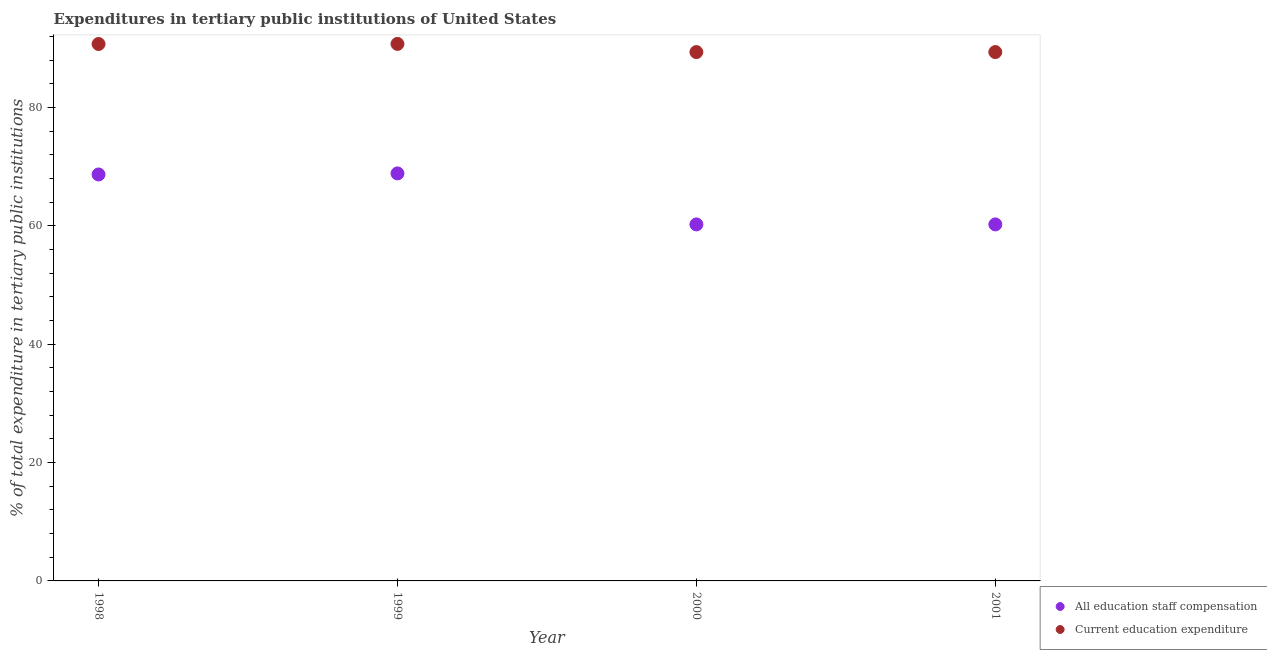How many different coloured dotlines are there?
Provide a short and direct response. 2. What is the expenditure in education in 1999?
Your response must be concise. 90.74. Across all years, what is the maximum expenditure in staff compensation?
Ensure brevity in your answer.  68.86. Across all years, what is the minimum expenditure in staff compensation?
Your answer should be compact. 60.24. In which year was the expenditure in staff compensation maximum?
Offer a very short reply. 1999. What is the total expenditure in education in the graph?
Keep it short and to the point. 360.19. What is the difference between the expenditure in staff compensation in 1998 and that in 2000?
Your response must be concise. 8.44. What is the difference between the expenditure in staff compensation in 2001 and the expenditure in education in 2000?
Your answer should be compact. -29.12. What is the average expenditure in staff compensation per year?
Provide a succinct answer. 64.51. In the year 1998, what is the difference between the expenditure in staff compensation and expenditure in education?
Your answer should be compact. -22.05. What is the ratio of the expenditure in staff compensation in 1999 to that in 2001?
Your answer should be compact. 1.14. What is the difference between the highest and the second highest expenditure in staff compensation?
Give a very brief answer. 0.18. What is the difference between the highest and the lowest expenditure in staff compensation?
Keep it short and to the point. 8.62. Does the expenditure in education monotonically increase over the years?
Give a very brief answer. No. Is the expenditure in staff compensation strictly greater than the expenditure in education over the years?
Provide a succinct answer. No. Is the expenditure in education strictly less than the expenditure in staff compensation over the years?
Ensure brevity in your answer.  No. What is the difference between two consecutive major ticks on the Y-axis?
Offer a terse response. 20. Are the values on the major ticks of Y-axis written in scientific E-notation?
Provide a short and direct response. No. Does the graph contain any zero values?
Offer a very short reply. No. Does the graph contain grids?
Give a very brief answer. No. Where does the legend appear in the graph?
Your answer should be very brief. Bottom right. How are the legend labels stacked?
Make the answer very short. Vertical. What is the title of the graph?
Keep it short and to the point. Expenditures in tertiary public institutions of United States. What is the label or title of the Y-axis?
Your answer should be very brief. % of total expenditure in tertiary public institutions. What is the % of total expenditure in tertiary public institutions of All education staff compensation in 1998?
Make the answer very short. 68.68. What is the % of total expenditure in tertiary public institutions of Current education expenditure in 1998?
Make the answer very short. 90.73. What is the % of total expenditure in tertiary public institutions in All education staff compensation in 1999?
Your response must be concise. 68.86. What is the % of total expenditure in tertiary public institutions of Current education expenditure in 1999?
Give a very brief answer. 90.74. What is the % of total expenditure in tertiary public institutions in All education staff compensation in 2000?
Make the answer very short. 60.24. What is the % of total expenditure in tertiary public institutions of Current education expenditure in 2000?
Ensure brevity in your answer.  89.36. What is the % of total expenditure in tertiary public institutions of All education staff compensation in 2001?
Make the answer very short. 60.24. What is the % of total expenditure in tertiary public institutions in Current education expenditure in 2001?
Your response must be concise. 89.36. Across all years, what is the maximum % of total expenditure in tertiary public institutions of All education staff compensation?
Make the answer very short. 68.86. Across all years, what is the maximum % of total expenditure in tertiary public institutions in Current education expenditure?
Offer a terse response. 90.74. Across all years, what is the minimum % of total expenditure in tertiary public institutions of All education staff compensation?
Provide a short and direct response. 60.24. Across all years, what is the minimum % of total expenditure in tertiary public institutions of Current education expenditure?
Give a very brief answer. 89.36. What is the total % of total expenditure in tertiary public institutions of All education staff compensation in the graph?
Ensure brevity in your answer.  258.02. What is the total % of total expenditure in tertiary public institutions of Current education expenditure in the graph?
Your answer should be very brief. 360.19. What is the difference between the % of total expenditure in tertiary public institutions of All education staff compensation in 1998 and that in 1999?
Keep it short and to the point. -0.18. What is the difference between the % of total expenditure in tertiary public institutions of Current education expenditure in 1998 and that in 1999?
Ensure brevity in your answer.  -0.02. What is the difference between the % of total expenditure in tertiary public institutions in All education staff compensation in 1998 and that in 2000?
Give a very brief answer. 8.44. What is the difference between the % of total expenditure in tertiary public institutions in Current education expenditure in 1998 and that in 2000?
Make the answer very short. 1.36. What is the difference between the % of total expenditure in tertiary public institutions of All education staff compensation in 1998 and that in 2001?
Your answer should be very brief. 8.44. What is the difference between the % of total expenditure in tertiary public institutions in Current education expenditure in 1998 and that in 2001?
Make the answer very short. 1.36. What is the difference between the % of total expenditure in tertiary public institutions of All education staff compensation in 1999 and that in 2000?
Offer a terse response. 8.62. What is the difference between the % of total expenditure in tertiary public institutions of Current education expenditure in 1999 and that in 2000?
Provide a succinct answer. 1.38. What is the difference between the % of total expenditure in tertiary public institutions in All education staff compensation in 1999 and that in 2001?
Your answer should be compact. 8.62. What is the difference between the % of total expenditure in tertiary public institutions of Current education expenditure in 1999 and that in 2001?
Your response must be concise. 1.38. What is the difference between the % of total expenditure in tertiary public institutions of Current education expenditure in 2000 and that in 2001?
Your response must be concise. 0. What is the difference between the % of total expenditure in tertiary public institutions of All education staff compensation in 1998 and the % of total expenditure in tertiary public institutions of Current education expenditure in 1999?
Offer a terse response. -22.06. What is the difference between the % of total expenditure in tertiary public institutions of All education staff compensation in 1998 and the % of total expenditure in tertiary public institutions of Current education expenditure in 2000?
Keep it short and to the point. -20.68. What is the difference between the % of total expenditure in tertiary public institutions of All education staff compensation in 1998 and the % of total expenditure in tertiary public institutions of Current education expenditure in 2001?
Your response must be concise. -20.68. What is the difference between the % of total expenditure in tertiary public institutions in All education staff compensation in 1999 and the % of total expenditure in tertiary public institutions in Current education expenditure in 2000?
Offer a terse response. -20.5. What is the difference between the % of total expenditure in tertiary public institutions of All education staff compensation in 1999 and the % of total expenditure in tertiary public institutions of Current education expenditure in 2001?
Give a very brief answer. -20.5. What is the difference between the % of total expenditure in tertiary public institutions in All education staff compensation in 2000 and the % of total expenditure in tertiary public institutions in Current education expenditure in 2001?
Ensure brevity in your answer.  -29.12. What is the average % of total expenditure in tertiary public institutions in All education staff compensation per year?
Ensure brevity in your answer.  64.51. What is the average % of total expenditure in tertiary public institutions in Current education expenditure per year?
Ensure brevity in your answer.  90.05. In the year 1998, what is the difference between the % of total expenditure in tertiary public institutions of All education staff compensation and % of total expenditure in tertiary public institutions of Current education expenditure?
Provide a succinct answer. -22.05. In the year 1999, what is the difference between the % of total expenditure in tertiary public institutions in All education staff compensation and % of total expenditure in tertiary public institutions in Current education expenditure?
Keep it short and to the point. -21.88. In the year 2000, what is the difference between the % of total expenditure in tertiary public institutions in All education staff compensation and % of total expenditure in tertiary public institutions in Current education expenditure?
Offer a very short reply. -29.12. In the year 2001, what is the difference between the % of total expenditure in tertiary public institutions of All education staff compensation and % of total expenditure in tertiary public institutions of Current education expenditure?
Provide a succinct answer. -29.12. What is the ratio of the % of total expenditure in tertiary public institutions of Current education expenditure in 1998 to that in 1999?
Offer a terse response. 1. What is the ratio of the % of total expenditure in tertiary public institutions in All education staff compensation in 1998 to that in 2000?
Keep it short and to the point. 1.14. What is the ratio of the % of total expenditure in tertiary public institutions of Current education expenditure in 1998 to that in 2000?
Ensure brevity in your answer.  1.02. What is the ratio of the % of total expenditure in tertiary public institutions of All education staff compensation in 1998 to that in 2001?
Offer a terse response. 1.14. What is the ratio of the % of total expenditure in tertiary public institutions in Current education expenditure in 1998 to that in 2001?
Ensure brevity in your answer.  1.02. What is the ratio of the % of total expenditure in tertiary public institutions of All education staff compensation in 1999 to that in 2000?
Offer a terse response. 1.14. What is the ratio of the % of total expenditure in tertiary public institutions in Current education expenditure in 1999 to that in 2000?
Provide a succinct answer. 1.02. What is the ratio of the % of total expenditure in tertiary public institutions in All education staff compensation in 1999 to that in 2001?
Keep it short and to the point. 1.14. What is the ratio of the % of total expenditure in tertiary public institutions in Current education expenditure in 1999 to that in 2001?
Offer a terse response. 1.02. What is the difference between the highest and the second highest % of total expenditure in tertiary public institutions in All education staff compensation?
Your answer should be compact. 0.18. What is the difference between the highest and the second highest % of total expenditure in tertiary public institutions in Current education expenditure?
Your answer should be very brief. 0.02. What is the difference between the highest and the lowest % of total expenditure in tertiary public institutions of All education staff compensation?
Your answer should be very brief. 8.62. What is the difference between the highest and the lowest % of total expenditure in tertiary public institutions in Current education expenditure?
Provide a succinct answer. 1.38. 